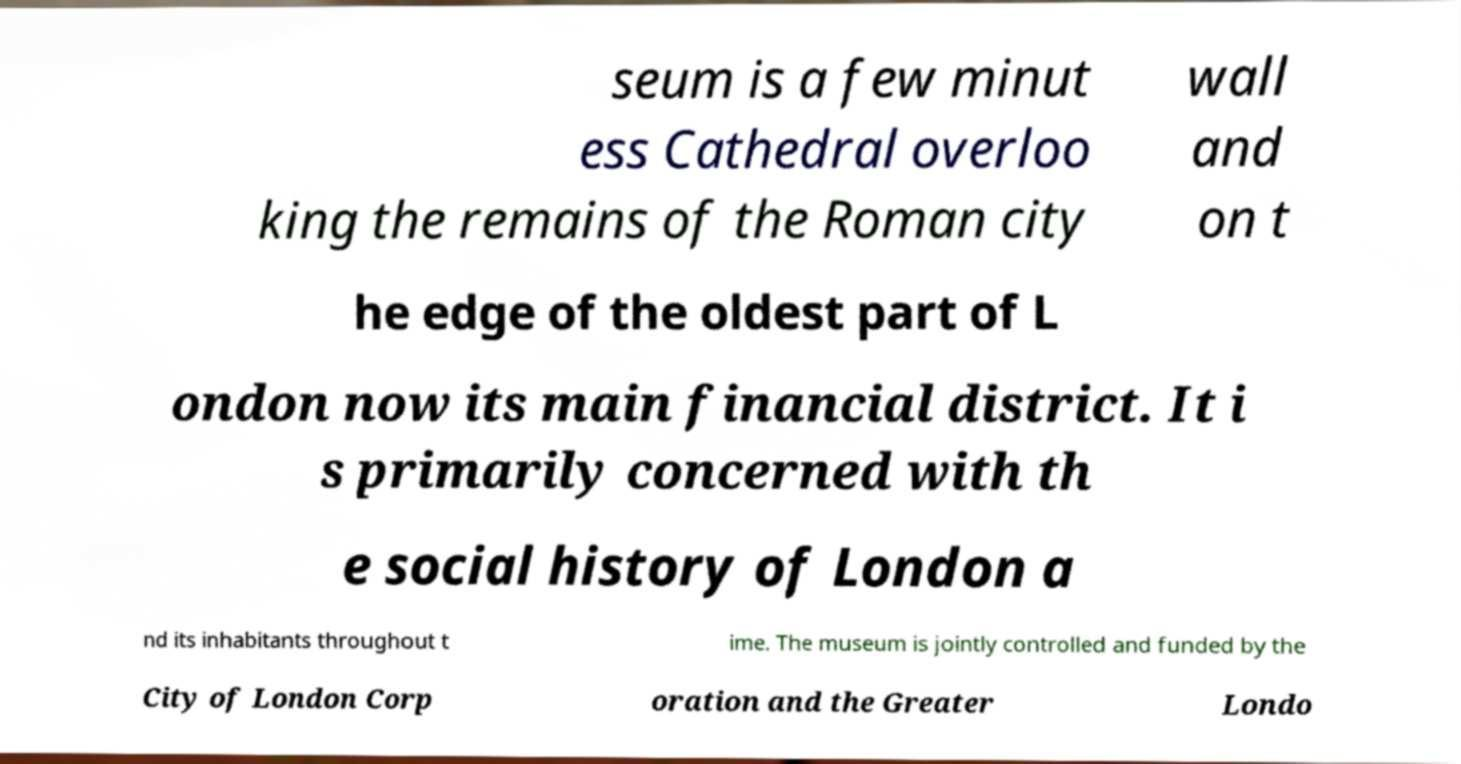Could you assist in decoding the text presented in this image and type it out clearly? seum is a few minut ess Cathedral overloo king the remains of the Roman city wall and on t he edge of the oldest part of L ondon now its main financial district. It i s primarily concerned with th e social history of London a nd its inhabitants throughout t ime. The museum is jointly controlled and funded by the City of London Corp oration and the Greater Londo 